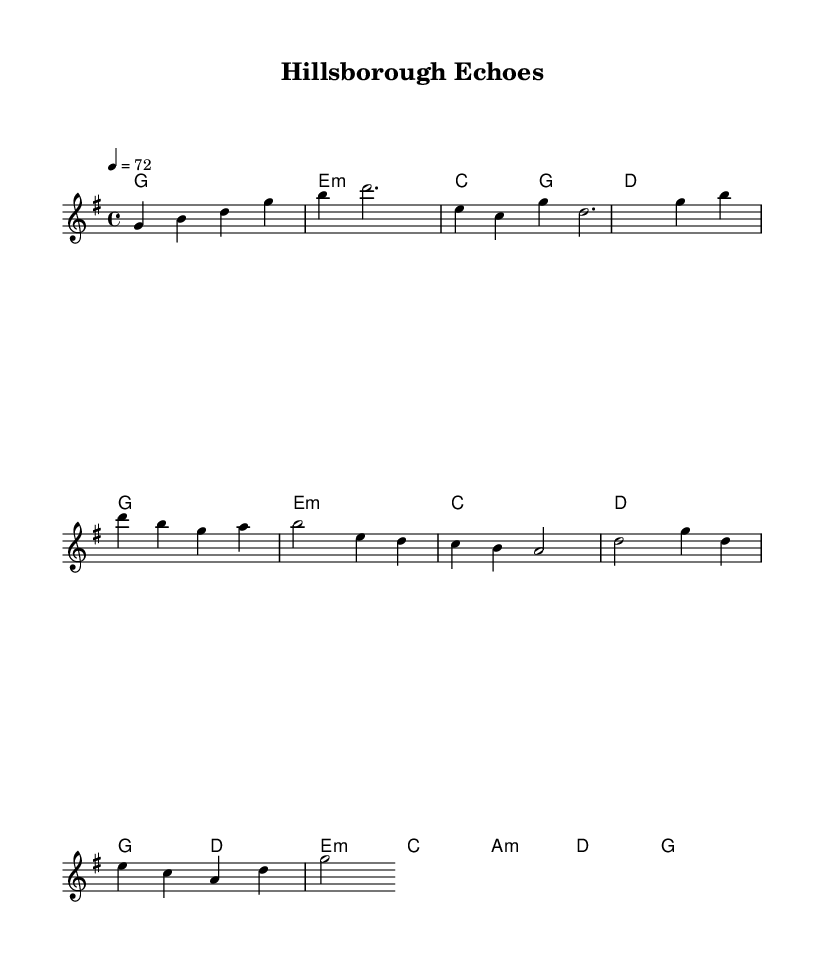What is the key signature of this music? The key signature is G major, which has one sharp (F#). This can be identified by observing the key signature indicator on the staff, which shows a single sharp.
Answer: G major What is the time signature of this music? The time signature is 4/4, which means there are four beats in each measure, and the quarter note receives one beat. This is indicated by the numbers shown at the beginning of the composition.
Answer: 4/4 What is the tempo of this music? The tempo is marked at 72 beats per minute, indicated by the tempo marking "4 = 72" at the beginning of the score. This tells us the speed at which the music should be played.
Answer: 72 What are the first two chords in the piece? The first two chords in the piece are G major and E minor, which can be determined by looking at the chord symbols above the staff at the beginning.
Answer: G major, E minor How many measures are in the intro section? The intro section contains four measures, which is confirmed by counting the vertical bar lines in that section of the score.
Answer: 4 In the chorus, which chord appears immediately after A minor? The chord that appears immediately after A minor in the chorus is D major, which can be identified by looking at the chord notations in the chorus section.
Answer: D major What is the significance of the melody's range in this piece? The melody primarily spans from G to G, indicating a comfortable vocal range typical of K-Pop ballads, catering to emotional expression while remaining accessible. This is inferred from observing the notes on the staff.
Answer: Comfortable vocal range 